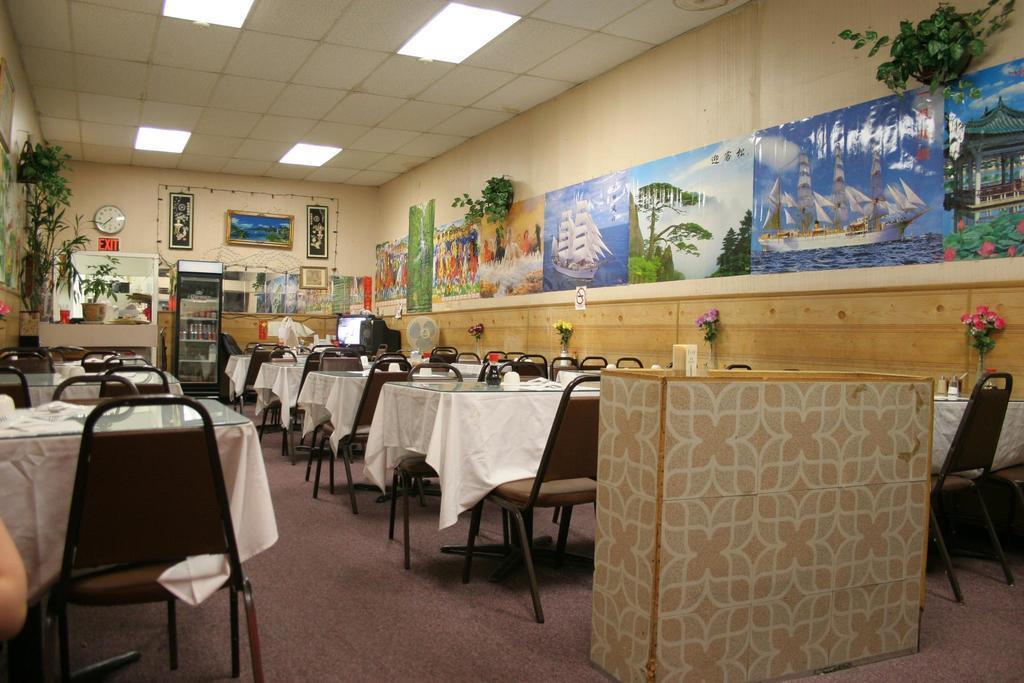Describe this image in one or two sentences. In the image we can see there are tables and chairs and in front there is a reception. Behind the is a refrigerator in which there are juice bottles and there are photo frames and a clock kept on the wall. 